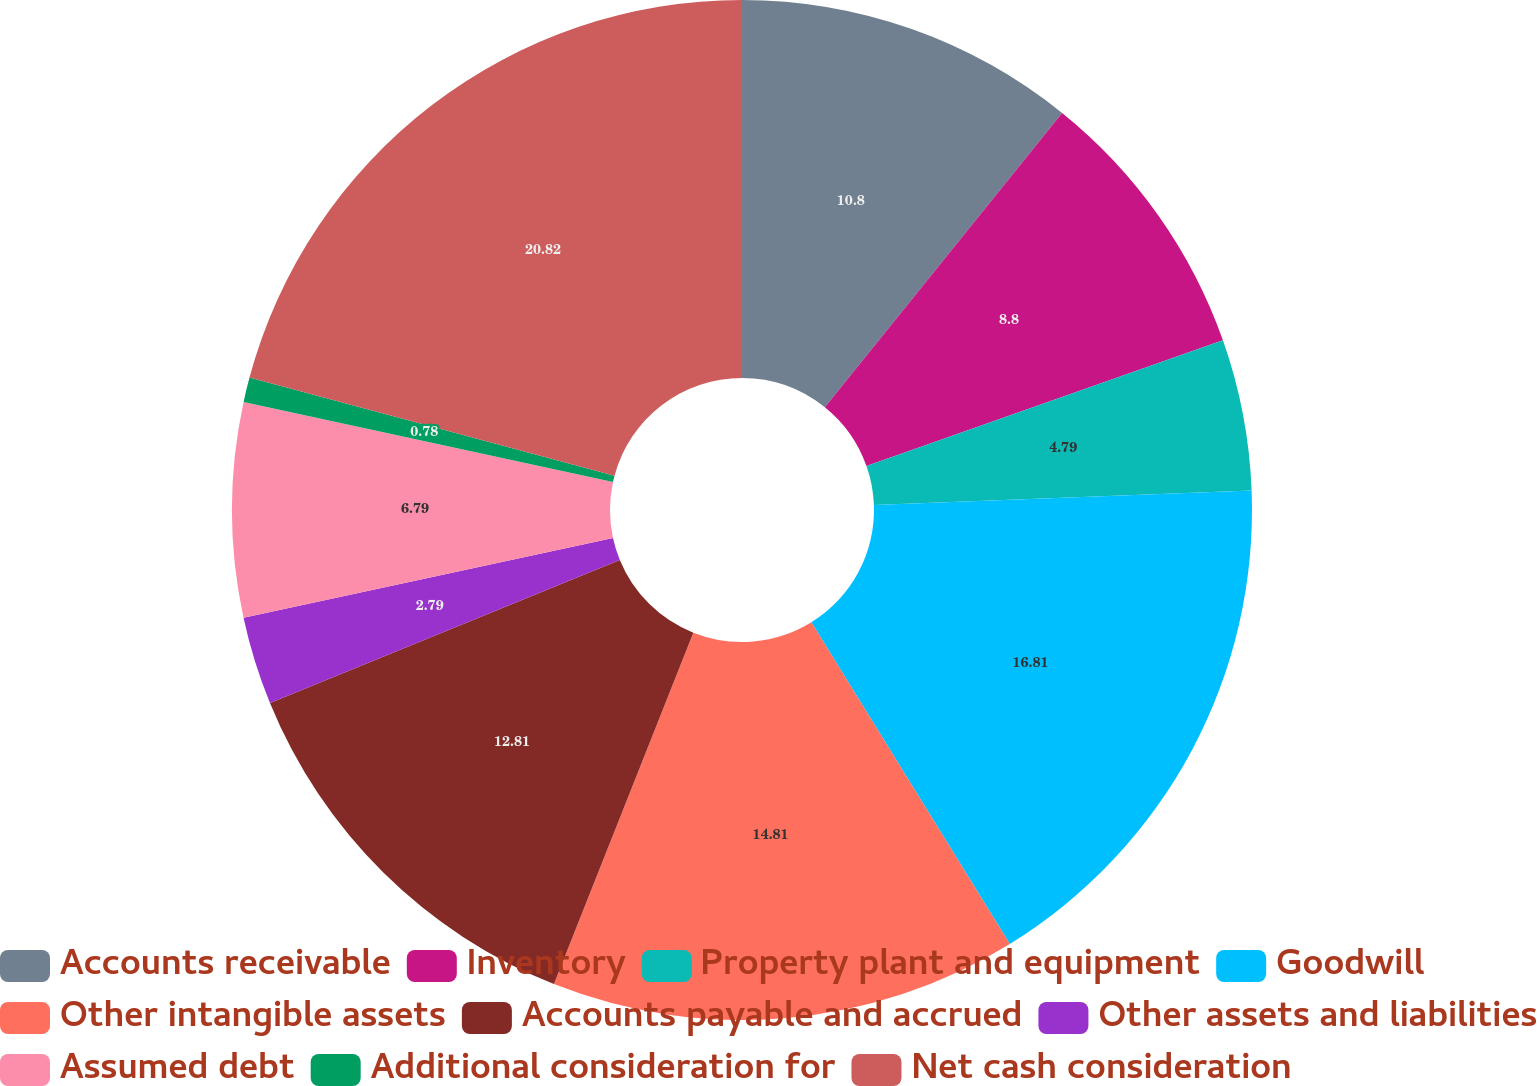Convert chart. <chart><loc_0><loc_0><loc_500><loc_500><pie_chart><fcel>Accounts receivable<fcel>Inventory<fcel>Property plant and equipment<fcel>Goodwill<fcel>Other intangible assets<fcel>Accounts payable and accrued<fcel>Other assets and liabilities<fcel>Assumed debt<fcel>Additional consideration for<fcel>Net cash consideration<nl><fcel>10.8%<fcel>8.8%<fcel>4.79%<fcel>16.81%<fcel>14.81%<fcel>12.81%<fcel>2.79%<fcel>6.79%<fcel>0.78%<fcel>20.82%<nl></chart> 